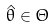<formula> <loc_0><loc_0><loc_500><loc_500>\hat { \theta } \in \Theta</formula> 